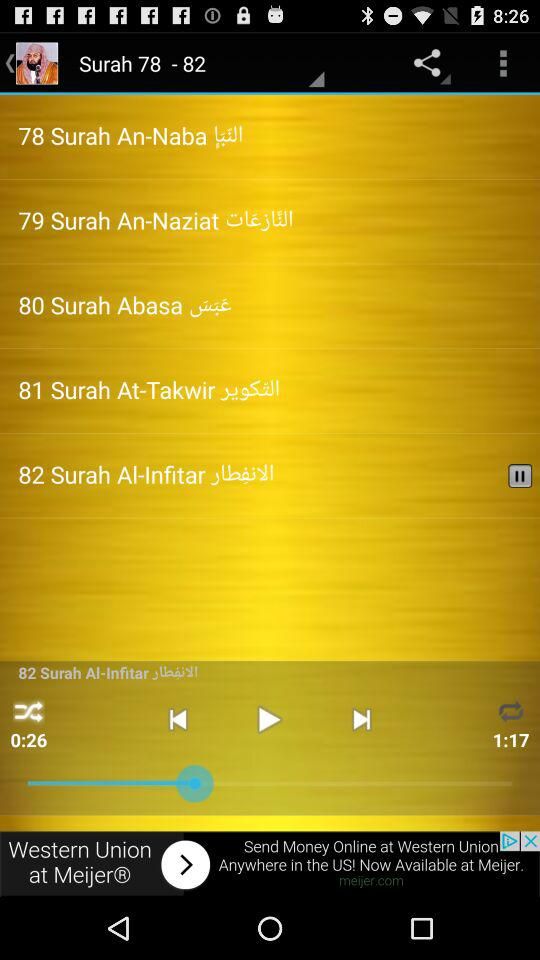Which surah was last played? The last played surah was "82 Surah Al-Infitar". 